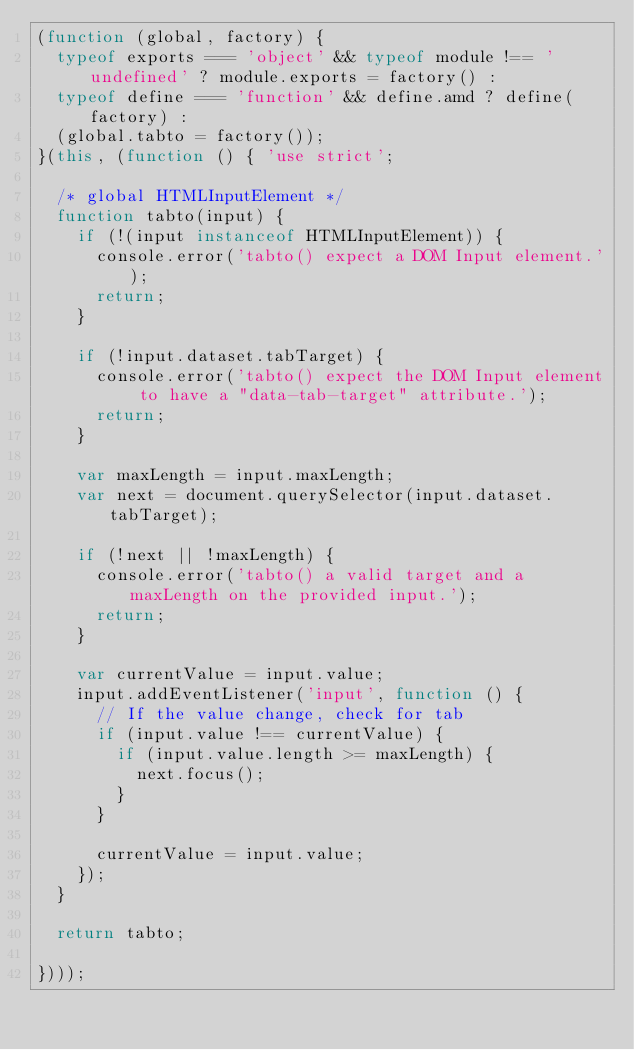<code> <loc_0><loc_0><loc_500><loc_500><_JavaScript_>(function (global, factory) {
  typeof exports === 'object' && typeof module !== 'undefined' ? module.exports = factory() :
  typeof define === 'function' && define.amd ? define(factory) :
  (global.tabto = factory());
}(this, (function () { 'use strict';

  /* global HTMLInputElement */
  function tabto(input) {
    if (!(input instanceof HTMLInputElement)) {
      console.error('tabto() expect a DOM Input element.');
      return;
    }

    if (!input.dataset.tabTarget) {
      console.error('tabto() expect the DOM Input element to have a "data-tab-target" attribute.');
      return;
    }

    var maxLength = input.maxLength;
    var next = document.querySelector(input.dataset.tabTarget);

    if (!next || !maxLength) {
      console.error('tabto() a valid target and a maxLength on the provided input.');
      return;
    }

    var currentValue = input.value;
    input.addEventListener('input', function () {
      // If the value change, check for tab
      if (input.value !== currentValue) {
        if (input.value.length >= maxLength) {
          next.focus();
        }
      }

      currentValue = input.value;
    });
  }

  return tabto;

})));
</code> 